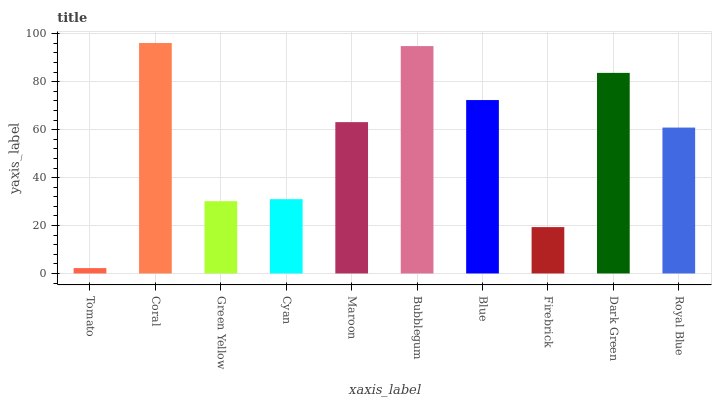Is Tomato the minimum?
Answer yes or no. Yes. Is Coral the maximum?
Answer yes or no. Yes. Is Green Yellow the minimum?
Answer yes or no. No. Is Green Yellow the maximum?
Answer yes or no. No. Is Coral greater than Green Yellow?
Answer yes or no. Yes. Is Green Yellow less than Coral?
Answer yes or no. Yes. Is Green Yellow greater than Coral?
Answer yes or no. No. Is Coral less than Green Yellow?
Answer yes or no. No. Is Maroon the high median?
Answer yes or no. Yes. Is Royal Blue the low median?
Answer yes or no. Yes. Is Cyan the high median?
Answer yes or no. No. Is Cyan the low median?
Answer yes or no. No. 